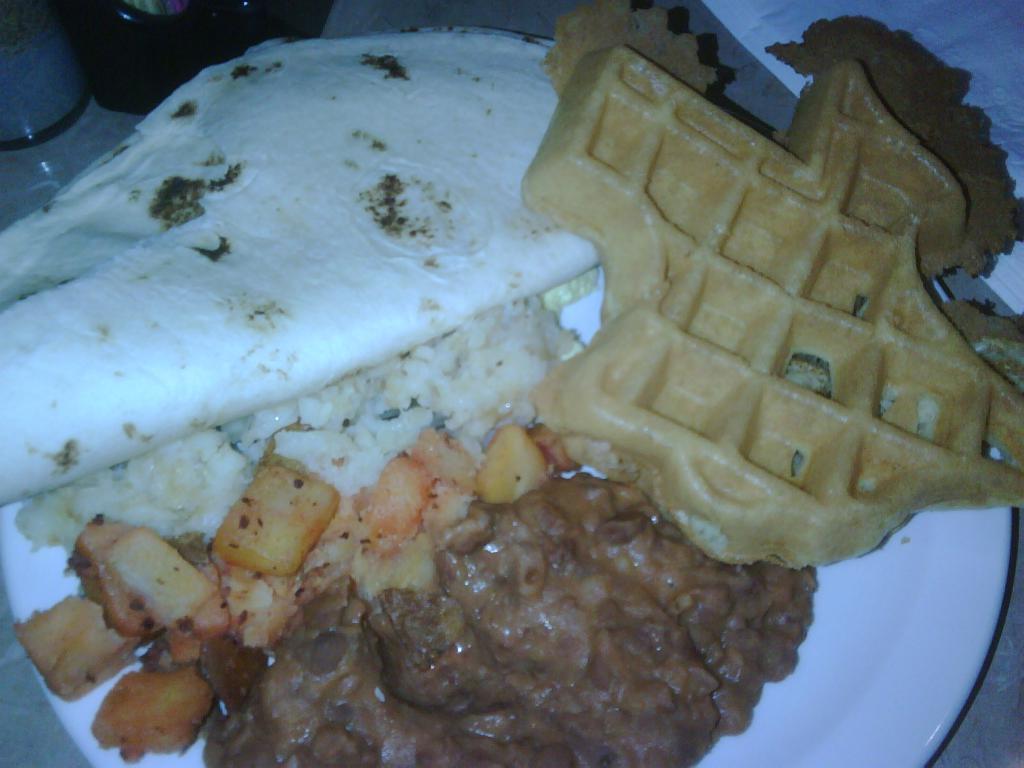Could you give a brief overview of what you see in this image? In the picture there is a plate with the food item, beside the plate there may be containers. 